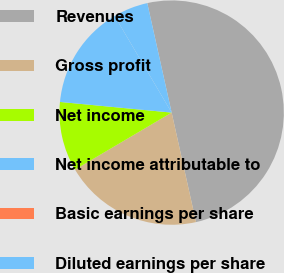Convert chart. <chart><loc_0><loc_0><loc_500><loc_500><pie_chart><fcel>Revenues<fcel>Gross profit<fcel>Net income<fcel>Net income attributable to<fcel>Basic earnings per share<fcel>Diluted earnings per share<nl><fcel>50.0%<fcel>20.0%<fcel>10.0%<fcel>15.0%<fcel>0.0%<fcel>5.0%<nl></chart> 